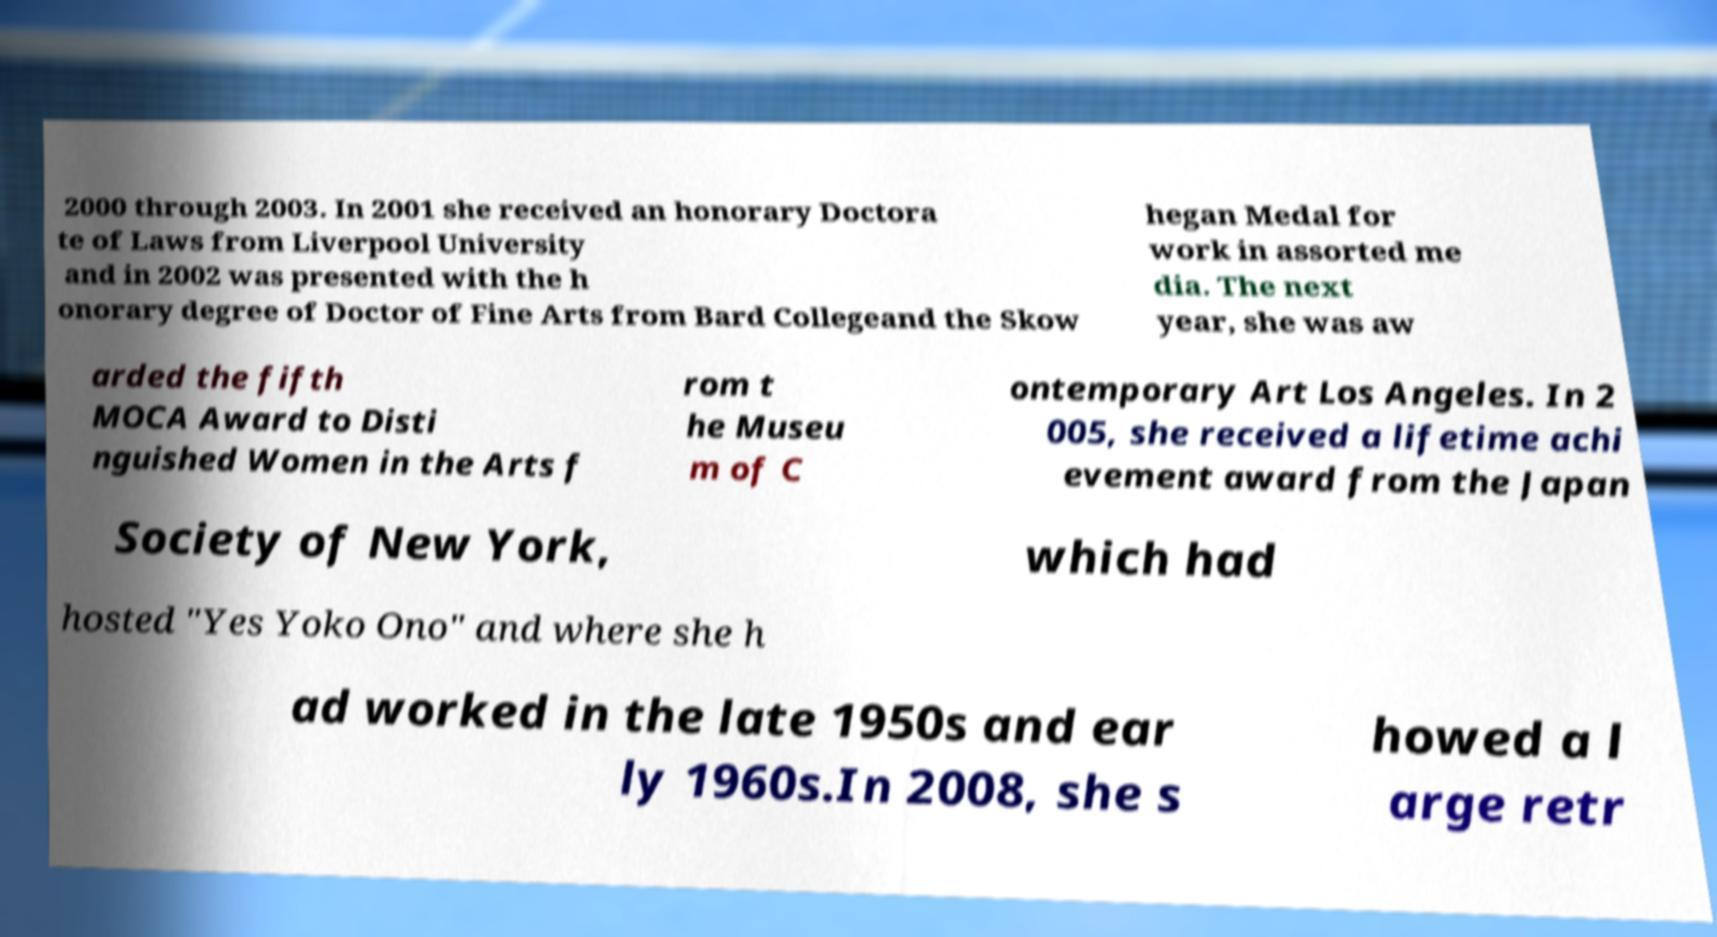For documentation purposes, I need the text within this image transcribed. Could you provide that? 2000 through 2003. In 2001 she received an honorary Doctora te of Laws from Liverpool University and in 2002 was presented with the h onorary degree of Doctor of Fine Arts from Bard Collegeand the Skow hegan Medal for work in assorted me dia. The next year, she was aw arded the fifth MOCA Award to Disti nguished Women in the Arts f rom t he Museu m of C ontemporary Art Los Angeles. In 2 005, she received a lifetime achi evement award from the Japan Society of New York, which had hosted "Yes Yoko Ono" and where she h ad worked in the late 1950s and ear ly 1960s.In 2008, she s howed a l arge retr 